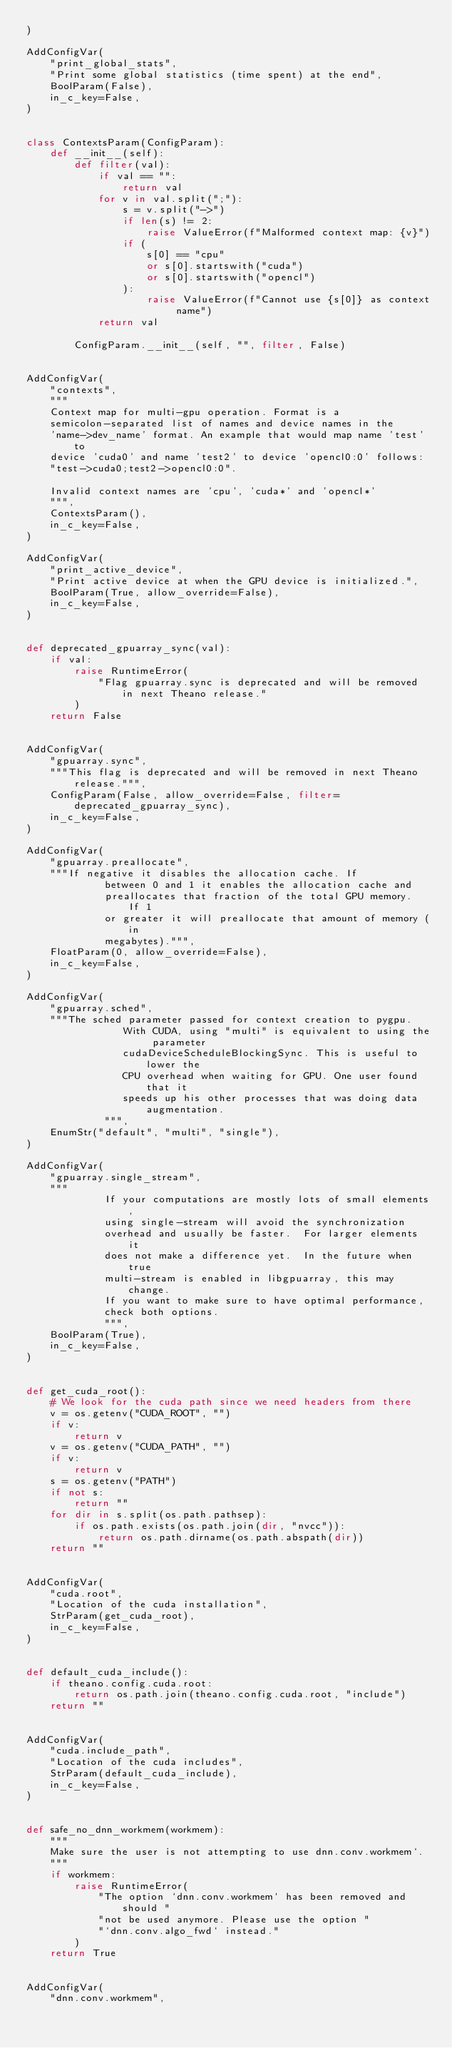Convert code to text. <code><loc_0><loc_0><loc_500><loc_500><_Python_>)

AddConfigVar(
    "print_global_stats",
    "Print some global statistics (time spent) at the end",
    BoolParam(False),
    in_c_key=False,
)


class ContextsParam(ConfigParam):
    def __init__(self):
        def filter(val):
            if val == "":
                return val
            for v in val.split(";"):
                s = v.split("->")
                if len(s) != 2:
                    raise ValueError(f"Malformed context map: {v}")
                if (
                    s[0] == "cpu"
                    or s[0].startswith("cuda")
                    or s[0].startswith("opencl")
                ):
                    raise ValueError(f"Cannot use {s[0]} as context name")
            return val

        ConfigParam.__init__(self, "", filter, False)


AddConfigVar(
    "contexts",
    """
    Context map for multi-gpu operation. Format is a
    semicolon-separated list of names and device names in the
    'name->dev_name' format. An example that would map name 'test' to
    device 'cuda0' and name 'test2' to device 'opencl0:0' follows:
    "test->cuda0;test2->opencl0:0".

    Invalid context names are 'cpu', 'cuda*' and 'opencl*'
    """,
    ContextsParam(),
    in_c_key=False,
)

AddConfigVar(
    "print_active_device",
    "Print active device at when the GPU device is initialized.",
    BoolParam(True, allow_override=False),
    in_c_key=False,
)


def deprecated_gpuarray_sync(val):
    if val:
        raise RuntimeError(
            "Flag gpuarray.sync is deprecated and will be removed in next Theano release."
        )
    return False


AddConfigVar(
    "gpuarray.sync",
    """This flag is deprecated and will be removed in next Theano release.""",
    ConfigParam(False, allow_override=False, filter=deprecated_gpuarray_sync),
    in_c_key=False,
)

AddConfigVar(
    "gpuarray.preallocate",
    """If negative it disables the allocation cache. If
             between 0 and 1 it enables the allocation cache and
             preallocates that fraction of the total GPU memory.  If 1
             or greater it will preallocate that amount of memory (in
             megabytes).""",
    FloatParam(0, allow_override=False),
    in_c_key=False,
)

AddConfigVar(
    "gpuarray.sched",
    """The sched parameter passed for context creation to pygpu.
                With CUDA, using "multi" is equivalent to using the parameter
                cudaDeviceScheduleBlockingSync. This is useful to lower the
                CPU overhead when waiting for GPU. One user found that it
                speeds up his other processes that was doing data augmentation.
             """,
    EnumStr("default", "multi", "single"),
)

AddConfigVar(
    "gpuarray.single_stream",
    """
             If your computations are mostly lots of small elements,
             using single-stream will avoid the synchronization
             overhead and usually be faster.  For larger elements it
             does not make a difference yet.  In the future when true
             multi-stream is enabled in libgpuarray, this may change.
             If you want to make sure to have optimal performance,
             check both options.
             """,
    BoolParam(True),
    in_c_key=False,
)


def get_cuda_root():
    # We look for the cuda path since we need headers from there
    v = os.getenv("CUDA_ROOT", "")
    if v:
        return v
    v = os.getenv("CUDA_PATH", "")
    if v:
        return v
    s = os.getenv("PATH")
    if not s:
        return ""
    for dir in s.split(os.path.pathsep):
        if os.path.exists(os.path.join(dir, "nvcc")):
            return os.path.dirname(os.path.abspath(dir))
    return ""


AddConfigVar(
    "cuda.root",
    "Location of the cuda installation",
    StrParam(get_cuda_root),
    in_c_key=False,
)


def default_cuda_include():
    if theano.config.cuda.root:
        return os.path.join(theano.config.cuda.root, "include")
    return ""


AddConfigVar(
    "cuda.include_path",
    "Location of the cuda includes",
    StrParam(default_cuda_include),
    in_c_key=False,
)


def safe_no_dnn_workmem(workmem):
    """
    Make sure the user is not attempting to use dnn.conv.workmem`.
    """
    if workmem:
        raise RuntimeError(
            "The option `dnn.conv.workmem` has been removed and should "
            "not be used anymore. Please use the option "
            "`dnn.conv.algo_fwd` instead."
        )
    return True


AddConfigVar(
    "dnn.conv.workmem",</code> 